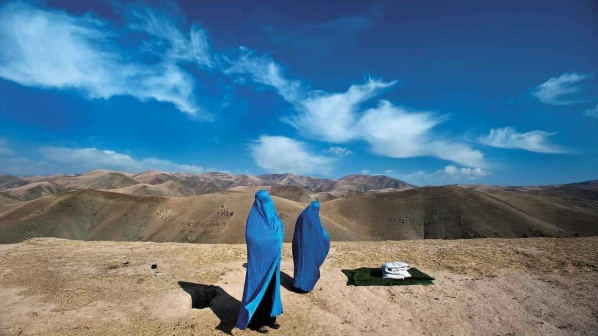Write a detailed description of the given image. In the image, there are two women cloaked in striking blue burqas standing on a rocky hilltop. They are positioned close to each other, suggesting a deep conversation or a moment of companionship. The surrounding landscape is expansive, featuring a vast, mountainous terrain that extends as far as the eye can see. The clear, bright blue sky above is lightly adorned with wispy, ethereal clouds, adding to the sense of openness and serenity of the scene.

A black dog can be seen lying down nearby, seemingly relaxed and adding a sense of tranquility to the moment. On the ground near the women, a white cloth is spread out next to a darker one, possibly intended for sitting or as a makeshift picnic space. The scene exudes a peaceful pause amidst the natural beauty, providing a brief respite in their journey or conversation. The women and the dog create a harmonious presence within the rugged and majestic landscape, capturing a serene and reflective moment amidst the grandeur of nature. 